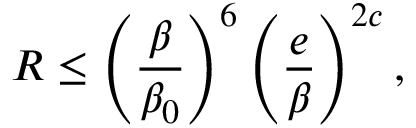<formula> <loc_0><loc_0><loc_500><loc_500>R \leq \left ( \frac { \beta } { \beta _ { 0 } } \right ) ^ { 6 } \left ( \frac { e } { \beta } \right ) ^ { 2 c } ,</formula> 